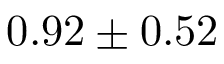Convert formula to latex. <formula><loc_0><loc_0><loc_500><loc_500>0 . 9 2 \pm 0 . 5 2</formula> 